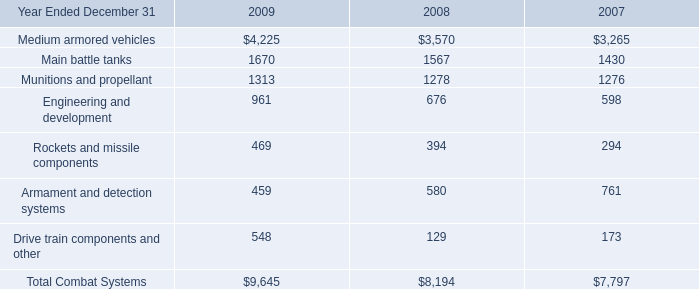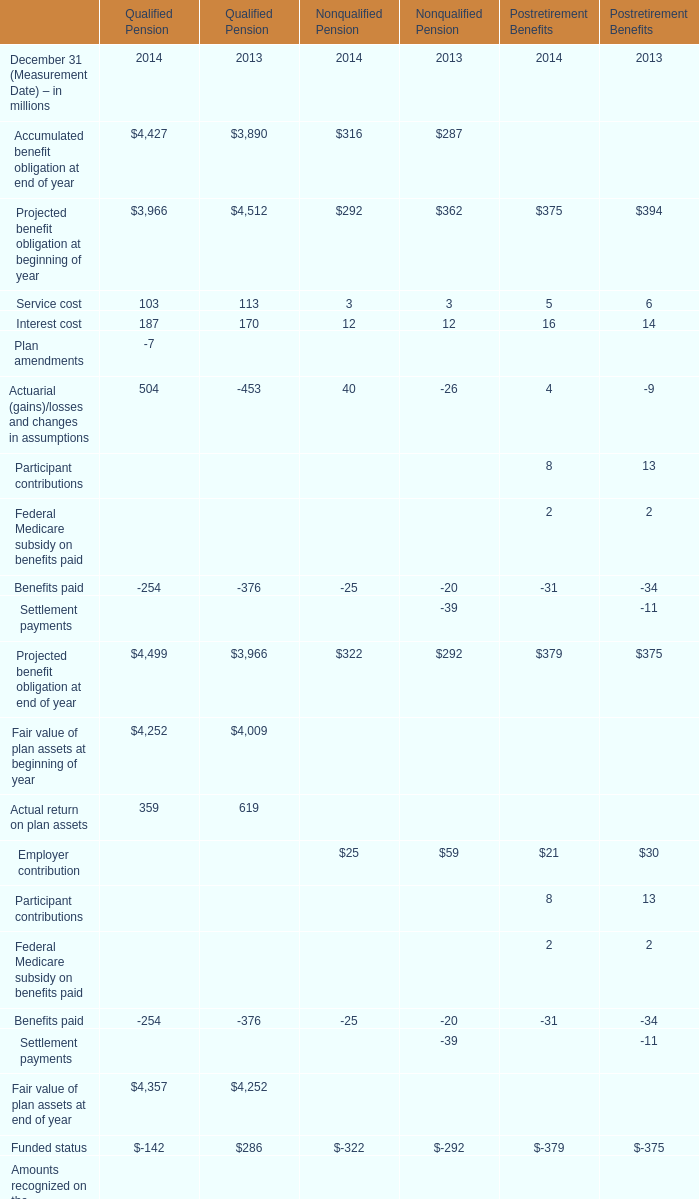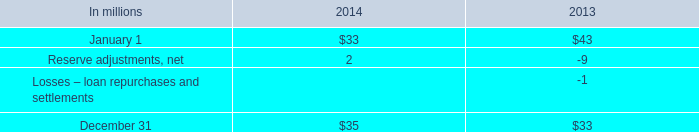what was the average balance in millions for commercial mortgage recourse obligations as of december 31 2014 and 2013? 
Computations: ((35 + 33) / 2)
Answer: 34.0. 